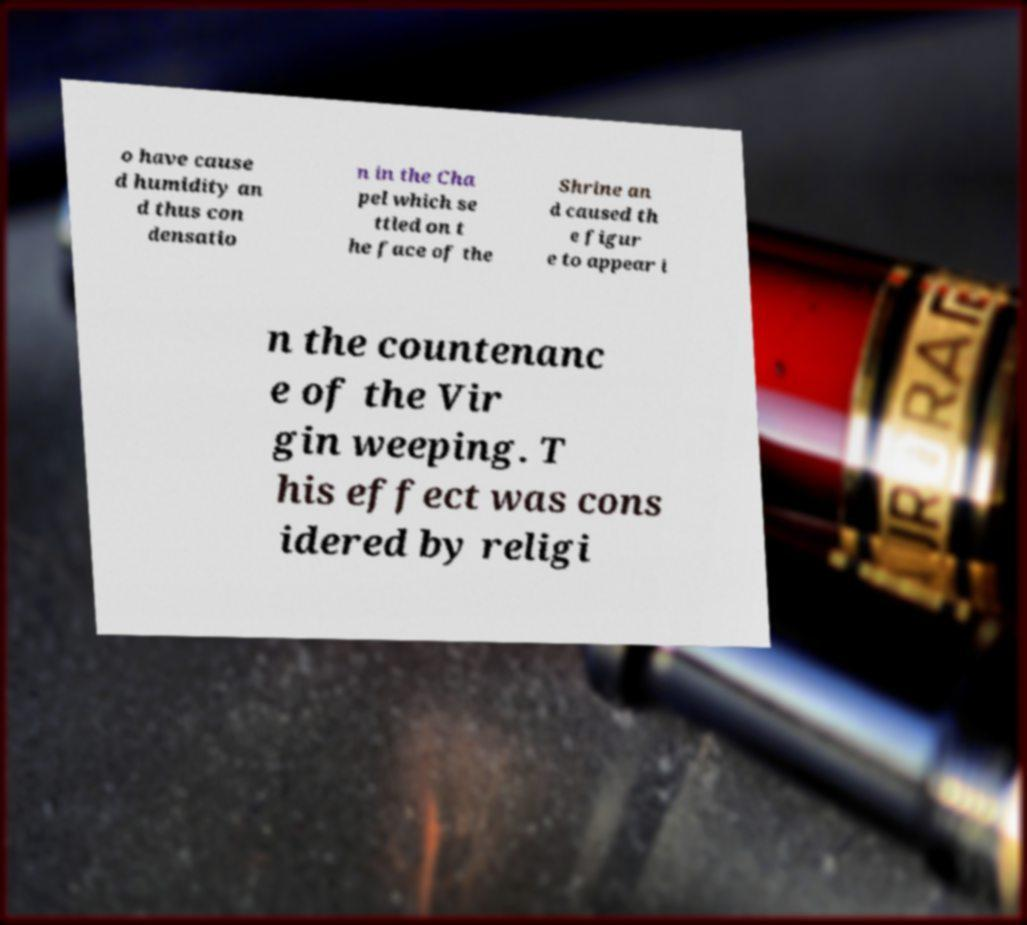For documentation purposes, I need the text within this image transcribed. Could you provide that? o have cause d humidity an d thus con densatio n in the Cha pel which se ttled on t he face of the Shrine an d caused th e figur e to appear i n the countenanc e of the Vir gin weeping. T his effect was cons idered by religi 